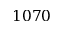<formula> <loc_0><loc_0><loc_500><loc_500>1 0 7 0</formula> 